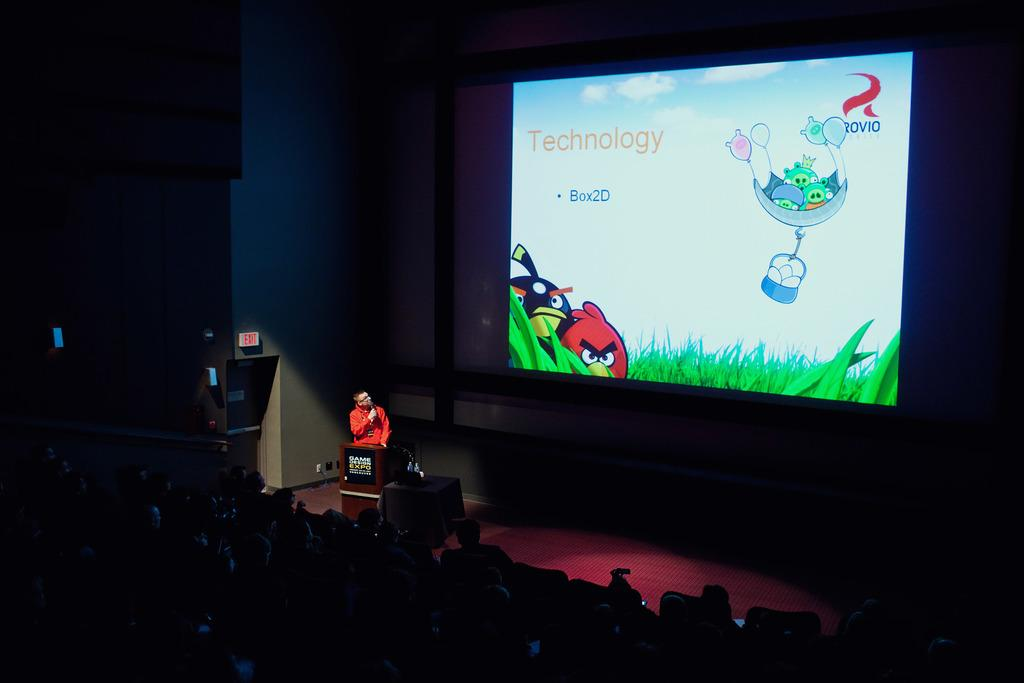<image>
Provide a brief description of the given image. A man is on stage in front of a large screen that says Technology Box2D. 